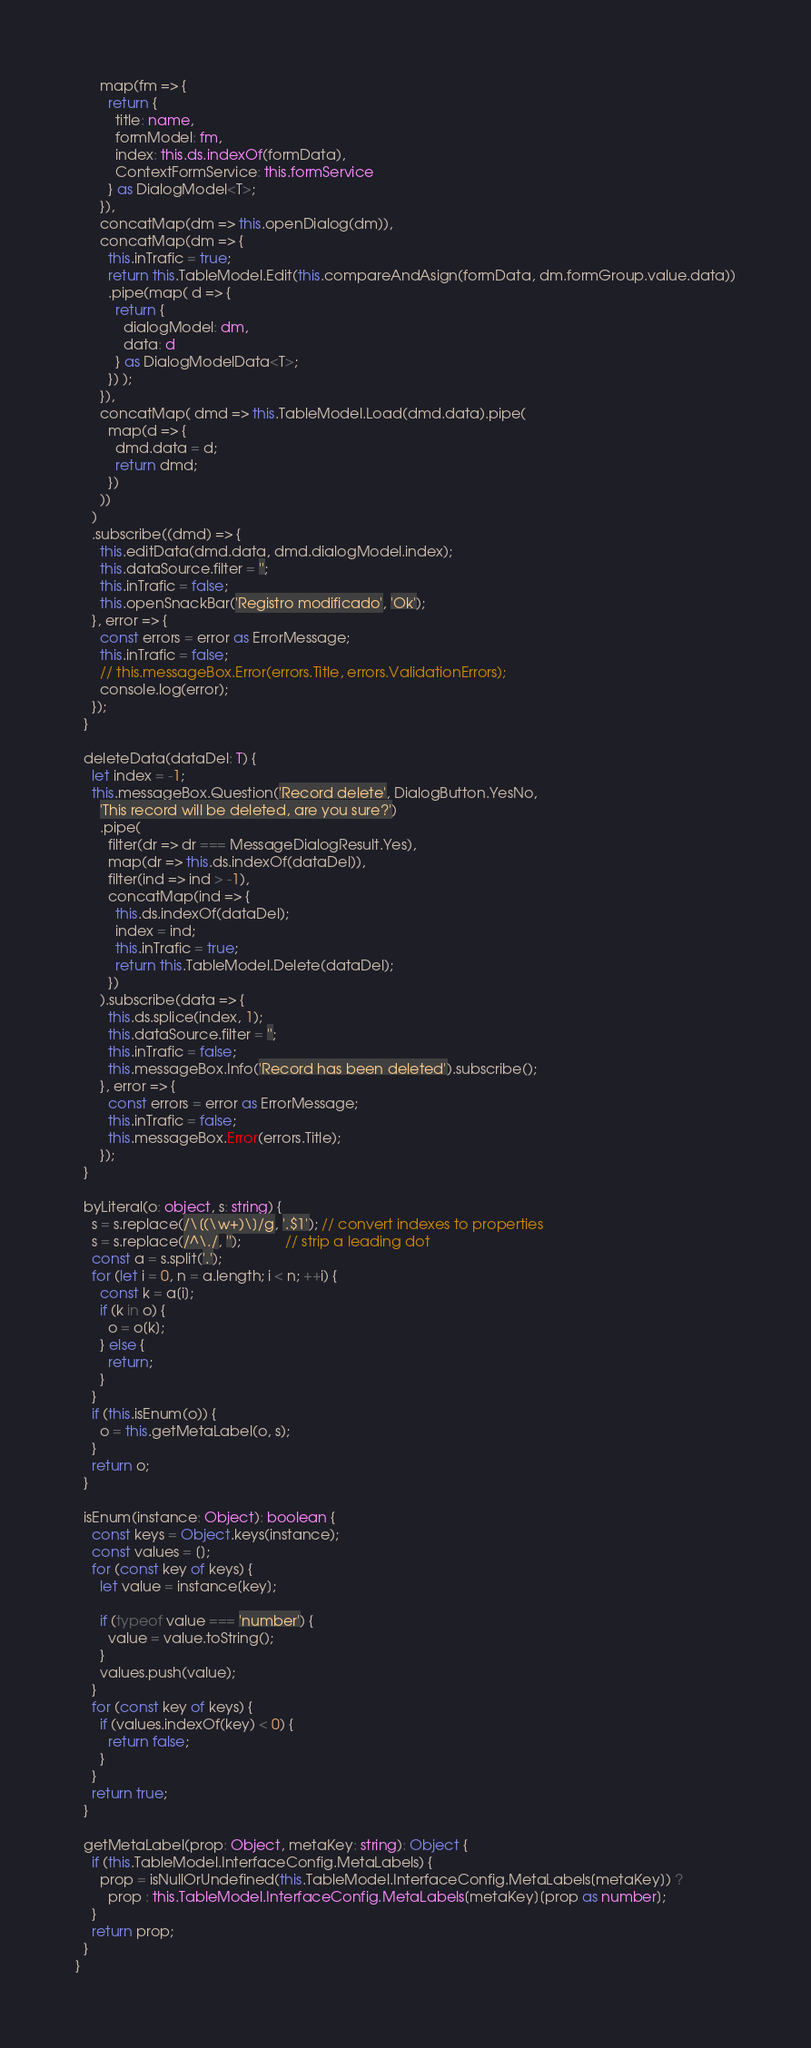Convert code to text. <code><loc_0><loc_0><loc_500><loc_500><_TypeScript_>      map(fm => {
        return {
          title: name,
          formModel: fm,
          index: this.ds.indexOf(formData),
          ContextFormService: this.formService
        } as DialogModel<T>;
      }),
      concatMap(dm => this.openDialog(dm)),
      concatMap(dm => {
        this.inTrafic = true;
        return this.TableModel.Edit(this.compareAndAsign(formData, dm.formGroup.value.data))
        .pipe(map( d => {
          return {
            dialogModel: dm,
            data: d
          } as DialogModelData<T>;
        }) );
      }),
      concatMap( dmd => this.TableModel.Load(dmd.data).pipe(
        map(d => {
          dmd.data = d;
          return dmd;
        })
      ))
    )
    .subscribe((dmd) => {
      this.editData(dmd.data, dmd.dialogModel.index);
      this.dataSource.filter = '';
      this.inTrafic = false;
      this.openSnackBar('Registro modificado', 'Ok');
    }, error => {
      const errors = error as ErrorMessage;
      this.inTrafic = false;
      // this.messageBox.Error(errors.Title, errors.ValidationErrors);
      console.log(error);
    });
  }

  deleteData(dataDel: T) {
    let index = -1;
    this.messageBox.Question('Record delete', DialogButton.YesNo,
      'This record will be deleted, are you sure?')
      .pipe(
        filter(dr => dr === MessageDialogResult.Yes),
        map(dr => this.ds.indexOf(dataDel)),
        filter(ind => ind > -1),
        concatMap(ind => {
          this.ds.indexOf(dataDel);
          index = ind;
          this.inTrafic = true;
          return this.TableModel.Delete(dataDel);
        })
      ).subscribe(data => {
        this.ds.splice(index, 1);
        this.dataSource.filter = '';
        this.inTrafic = false;
        this.messageBox.Info('Record has been deleted').subscribe();
      }, error => {
        const errors = error as ErrorMessage;
        this.inTrafic = false;
        this.messageBox.Error(errors.Title);
      });
  }

  byLiteral(o: object, s: string) {
    s = s.replace(/\[(\w+)\]/g, '.$1'); // convert indexes to properties
    s = s.replace(/^\./, '');           // strip a leading dot
    const a = s.split('.');
    for (let i = 0, n = a.length; i < n; ++i) {
      const k = a[i];
      if (k in o) {
        o = o[k];
      } else {
        return;
      }
    }
    if (this.isEnum(o)) {
      o = this.getMetaLabel(o, s);
    }
    return o;
  }

  isEnum(instance: Object): boolean {
    const keys = Object.keys(instance);
    const values = [];
    for (const key of keys) {
      let value = instance[key];

      if (typeof value === 'number') {
        value = value.toString();
      }
      values.push(value);
    }
    for (const key of keys) {
      if (values.indexOf(key) < 0) {
        return false;
      }
    }
    return true;
  }

  getMetaLabel(prop: Object, metaKey: string): Object {
    if (this.TableModel.InterfaceConfig.MetaLabels) {
      prop = isNullOrUndefined(this.TableModel.InterfaceConfig.MetaLabels[metaKey]) ?
        prop : this.TableModel.InterfaceConfig.MetaLabels[metaKey][prop as number];
    }
    return prop;
  }
}
</code> 